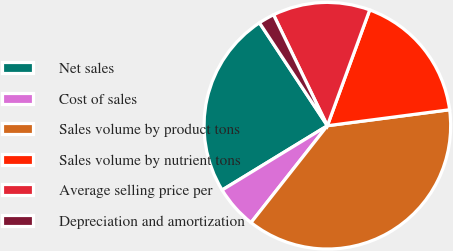Convert chart to OTSL. <chart><loc_0><loc_0><loc_500><loc_500><pie_chart><fcel>Net sales<fcel>Cost of sales<fcel>Sales volume by product tons<fcel>Sales volume by nutrient tons<fcel>Average selling price per<fcel>Depreciation and amortization<nl><fcel>24.45%<fcel>5.65%<fcel>37.69%<fcel>17.35%<fcel>12.77%<fcel>2.09%<nl></chart> 